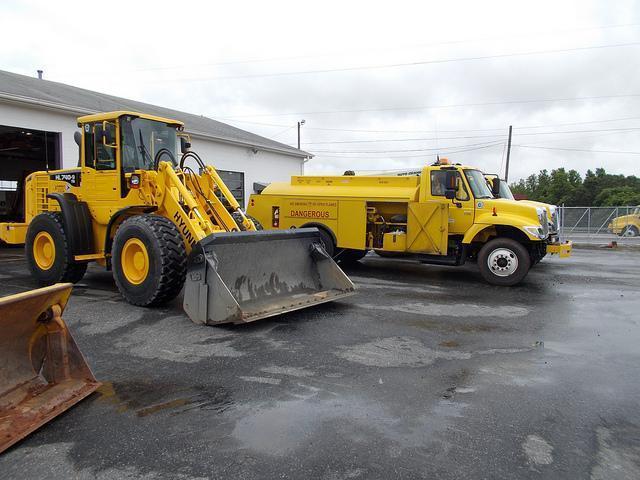How many yellow trucks are parked?
Give a very brief answer. 2. 